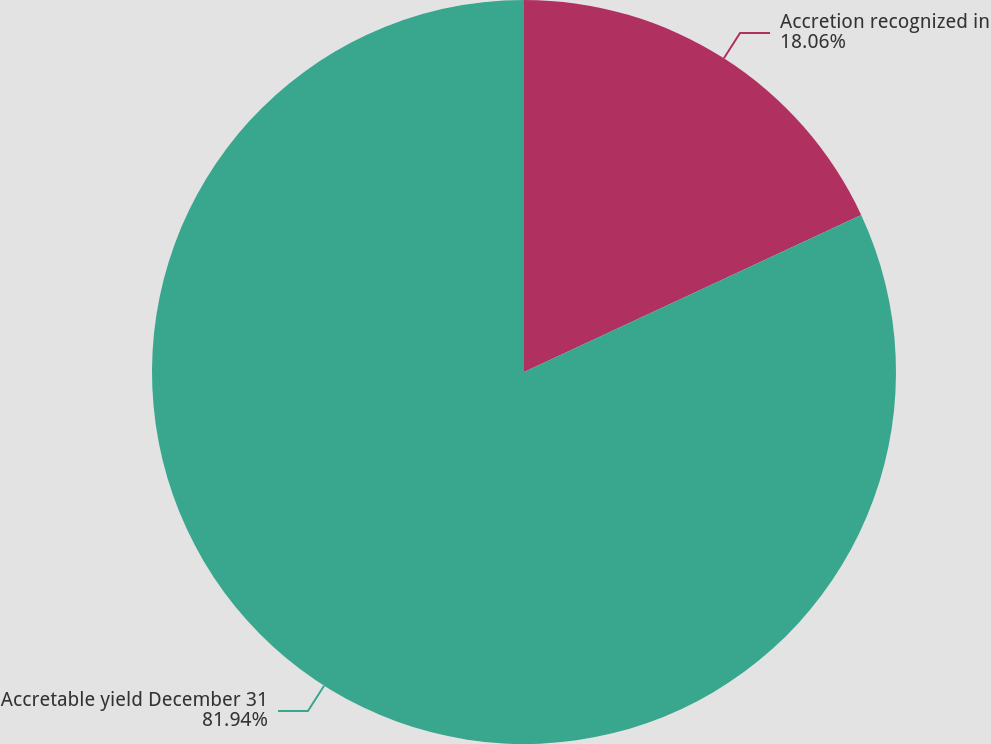<chart> <loc_0><loc_0><loc_500><loc_500><pie_chart><fcel>Accretion recognized in<fcel>Accretable yield December 31<nl><fcel>18.06%<fcel>81.94%<nl></chart> 